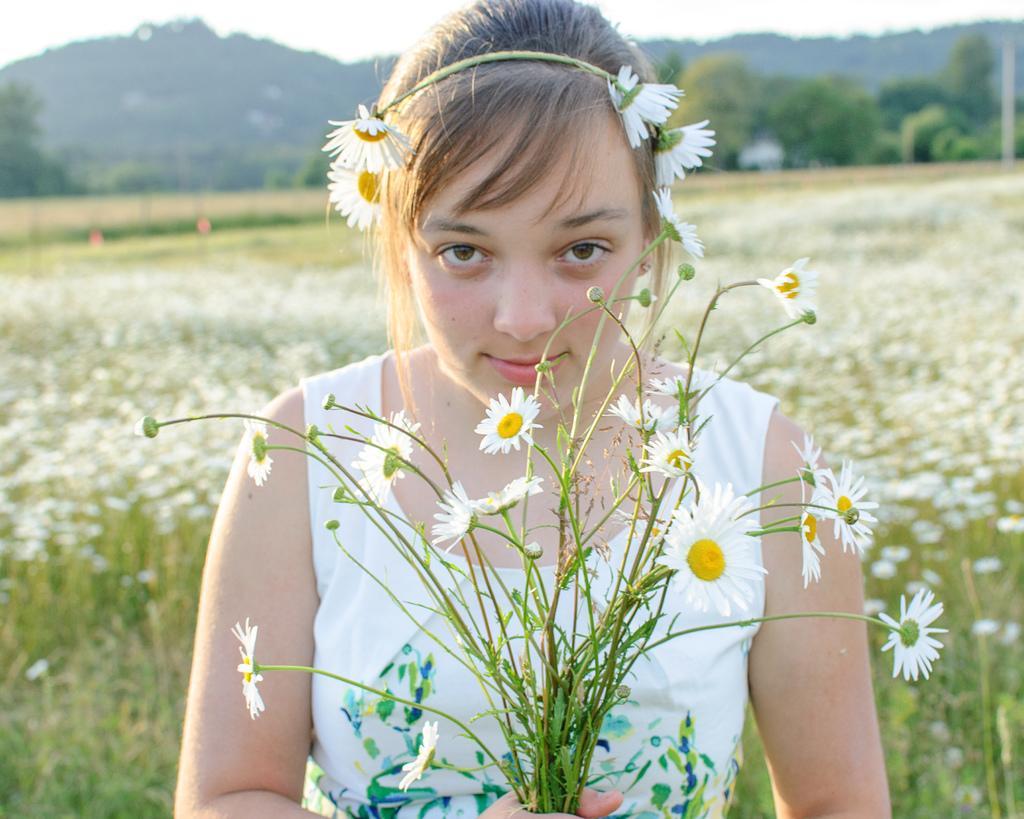Please provide a concise description of this image. In the image there is a girl in the foreground, she is holding some flowers in her hand, the background of the girl is blur. 